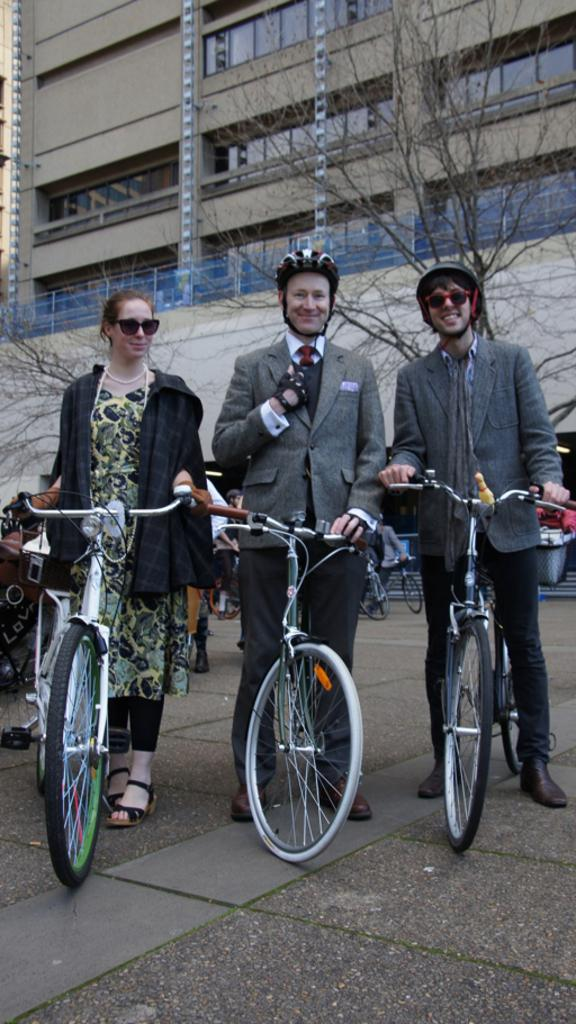What is the main subject of the image? The main subject of the image is a group of people. Can you describe the activity of some of the people in the image? Three people are standing with bicycles in the middle of the image. What can be seen in the background of the image? There is a building and trees in the background of the image. What type of glove is the person wearing while riding the bicycle in the image? There is no person wearing a glove while riding a bicycle in the image. How many shoes can be seen on the people in the image? The image does not show the shoes of the people, so it cannot be determined how many shoes are visible. 